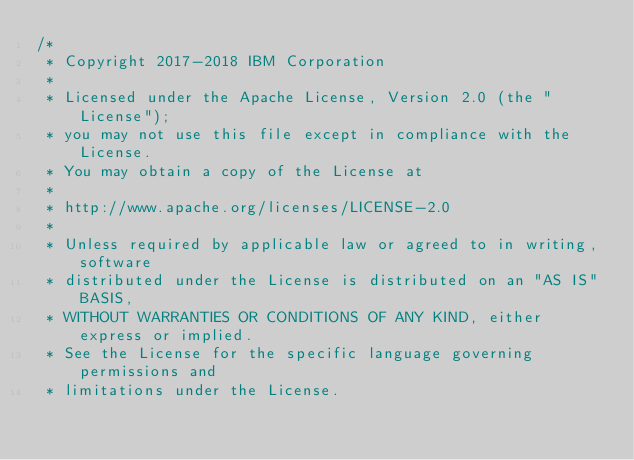Convert code to text. <code><loc_0><loc_0><loc_500><loc_500><_TypeScript_>/*
 * Copyright 2017-2018 IBM Corporation
 *
 * Licensed under the Apache License, Version 2.0 (the "License");
 * you may not use this file except in compliance with the License.
 * You may obtain a copy of the License at
 *
 * http://www.apache.org/licenses/LICENSE-2.0
 *
 * Unless required by applicable law or agreed to in writing, software
 * distributed under the License is distributed on an "AS IS" BASIS,
 * WITHOUT WARRANTIES OR CONDITIONS OF ANY KIND, either express or implied.
 * See the License for the specific language governing permissions and
 * limitations under the License.</code> 